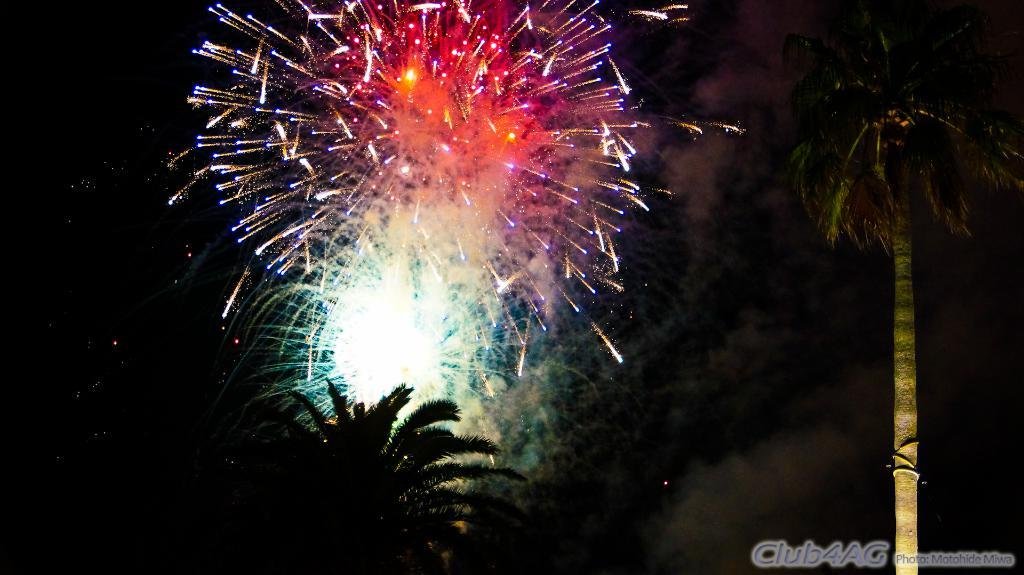What type of vegetation can be seen in the image? There are trees in the image. What is an unusual object that can be seen in the sky? There are crackers in the sky. What can be found at the bottom of the image? There is some text at the bottom of the image. What type of pot is visible in the image? There is no pot present in the image. What can be heard in the image? The image is a visual representation, so there is no sound or hearing involved. 